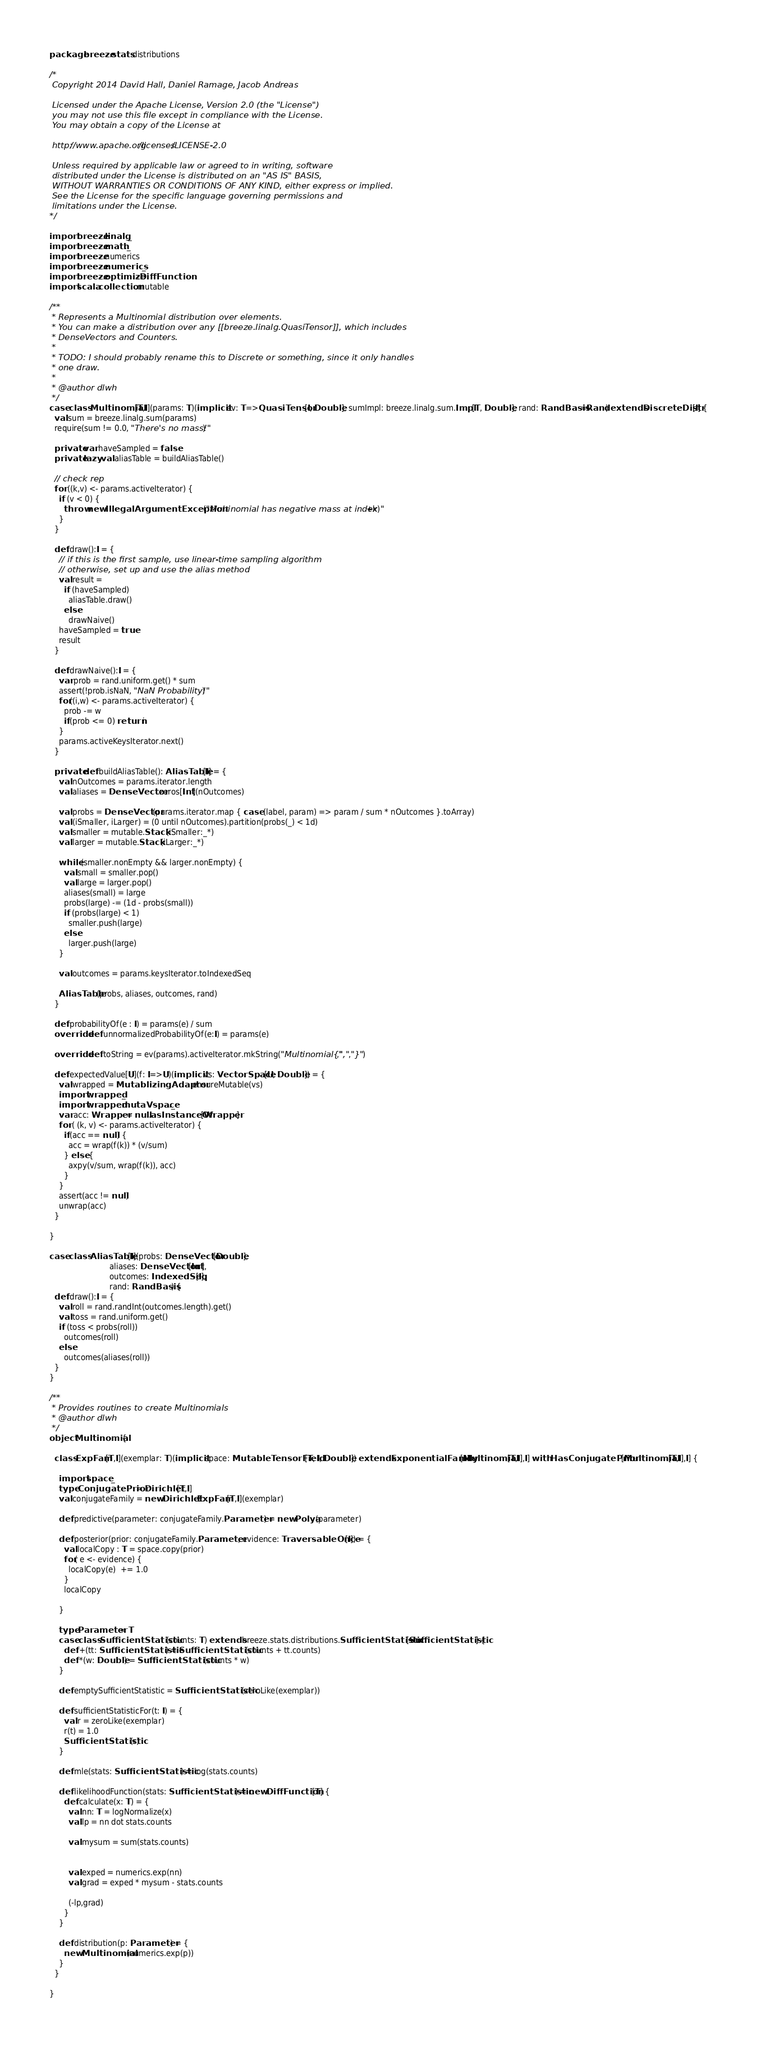Convert code to text. <code><loc_0><loc_0><loc_500><loc_500><_Scala_>package breeze.stats.distributions

/*
 Copyright 2014 David Hall, Daniel Ramage, Jacob Andreas
 
 Licensed under the Apache License, Version 2.0 (the "License")
 you may not use this file except in compliance with the License.
 You may obtain a copy of the License at 
 
 http://www.apache.org/licenses/LICENSE-2.0
 
 Unless required by applicable law or agreed to in writing, software
 distributed under the License is distributed on an "AS IS" BASIS,
 WITHOUT WARRANTIES OR CONDITIONS OF ANY KIND, either express or implied.
 See the License for the specific language governing permissions and
 limitations under the License. 
*/

import breeze.linalg._
import breeze.math._
import breeze.numerics
import breeze.numerics._
import breeze.optimize.DiffFunction
import scala.collection.mutable

/**
 * Represents a Multinomial distribution over elements.
 * You can make a distribution over any [[breeze.linalg.QuasiTensor]], which includes
 * DenseVectors and Counters.
 *
 * TODO: I should probably rename this to Discrete or something, since it only handles
 * one draw.
 *
 * @author dlwh
 */
case class Multinomial[T,I](params: T)(implicit ev: T=>QuasiTensor[I, Double], sumImpl: breeze.linalg.sum.Impl[T, Double], rand: RandBasis=Rand) extends DiscreteDistr[I] {
  val sum = breeze.linalg.sum(params)
  require(sum != 0.0, "There's no mass!")

  private var haveSampled = false
  private lazy val aliasTable = buildAliasTable()

  // check rep
  for ((k,v) <- params.activeIterator) {
    if (v < 0) {
      throw new IllegalArgumentException("Multinomial has negative mass at index "+k)
    }
  }

  def draw():I = {
    // if this is the first sample, use linear-time sampling algorithm
    // otherwise, set up and use the alias method
    val result =
      if (haveSampled)
        aliasTable.draw()
      else
        drawNaive()
    haveSampled = true
    result
  }

  def drawNaive():I = {
    var prob = rand.uniform.get() * sum
    assert(!prob.isNaN, "NaN Probability!")
    for((i,w) <- params.activeIterator) {
      prob -= w
      if(prob <= 0) return i
    }
    params.activeKeysIterator.next()
  }

  private def buildAliasTable(): AliasTable[I] = {
    val nOutcomes = params.iterator.length
    val aliases = DenseVector.zeros[Int](nOutcomes)

    val probs = DenseVector(params.iterator.map { case (label, param) => param / sum * nOutcomes }.toArray)
    val (iSmaller, iLarger) = (0 until nOutcomes).partition(probs(_) < 1d)
    val smaller = mutable.Stack(iSmaller:_*)
    val larger = mutable.Stack(iLarger:_*)

    while (smaller.nonEmpty && larger.nonEmpty) {
      val small = smaller.pop()
      val large = larger.pop()
      aliases(small) = large
      probs(large) -= (1d - probs(small))
      if (probs(large) < 1)
        smaller.push(large)
      else
        larger.push(large)
    }

    val outcomes = params.keysIterator.toIndexedSeq

    AliasTable(probs, aliases, outcomes, rand)
  }

  def probabilityOf(e : I) = params(e) / sum
  override def unnormalizedProbabilityOf(e:I) = params(e)

  override def toString = ev(params).activeIterator.mkString("Multinomial{",",","}")

  def expectedValue[U](f: I=>U)(implicit vs: VectorSpace[U, Double]) = {
    val wrapped = MutablizingAdaptor.ensureMutable(vs)
    import wrapped._
    import wrapped.mutaVspace._
    var acc: Wrapper = null.asInstanceOf[Wrapper]
    for ( (k, v) <- params.activeIterator) {
      if(acc == null) {
        acc = wrap(f(k)) * (v/sum)
      } else {
        axpy(v/sum, wrap(f(k)), acc)
      }
    }
    assert(acc != null)
    unwrap(acc)
  }

}

case class AliasTable[I](probs: DenseVector[Double], 
                         aliases: DenseVector[Int],
                         outcomes: IndexedSeq[I],
                         rand: RandBasis) {
  def draw():I = {
    val roll = rand.randInt(outcomes.length).get()
    val toss = rand.uniform.get()
    if (toss < probs(roll))
      outcomes(roll)
    else
      outcomes(aliases(roll))
  }
}

/**
 * Provides routines to create Multinomials
 * @author dlwh
 */
object Multinomial {

  class ExpFam[T,I](exemplar: T)(implicit space: MutableTensorField[T, I, Double]) extends ExponentialFamily[Multinomial[T,I],I] with HasConjugatePrior[Multinomial[T,I],I] {

    import space._
    type ConjugatePrior = Dirichlet[T,I]
    val conjugateFamily = new Dirichlet.ExpFam[T,I](exemplar)

    def predictive(parameter: conjugateFamily.Parameter) = new Polya(parameter)

    def posterior(prior: conjugateFamily.Parameter, evidence: TraversableOnce[I]) = {
      val localCopy : T = space.copy(prior)
      for( e <- evidence) {
        localCopy(e)  += 1.0
      }
      localCopy

    }

    type Parameter = T
    case class SufficientStatistic(counts: T) extends breeze.stats.distributions.SufficientStatistic[SufficientStatistic] {
      def +(tt: SufficientStatistic) = SufficientStatistic(counts + tt.counts)
      def *(w: Double) = SufficientStatistic(counts * w)
    }

    def emptySufficientStatistic = SufficientStatistic(zeroLike(exemplar))

    def sufficientStatisticFor(t: I) = {
      val r = zeroLike(exemplar)
      r(t) = 1.0
      SufficientStatistic(r)
    }

    def mle(stats: SufficientStatistic) = log(stats.counts)

    def likelihoodFunction(stats: SufficientStatistic) = new DiffFunction[T] {
      def calculate(x: T) = {
        val nn: T = logNormalize(x)
        val lp = nn dot stats.counts

        val mysum = sum(stats.counts)


        val exped = numerics.exp(nn)
        val grad = exped * mysum - stats.counts

        (-lp,grad)
      }
    }

    def distribution(p: Parameter) = {
      new Multinomial(numerics.exp(p))
    }
  }

}
</code> 